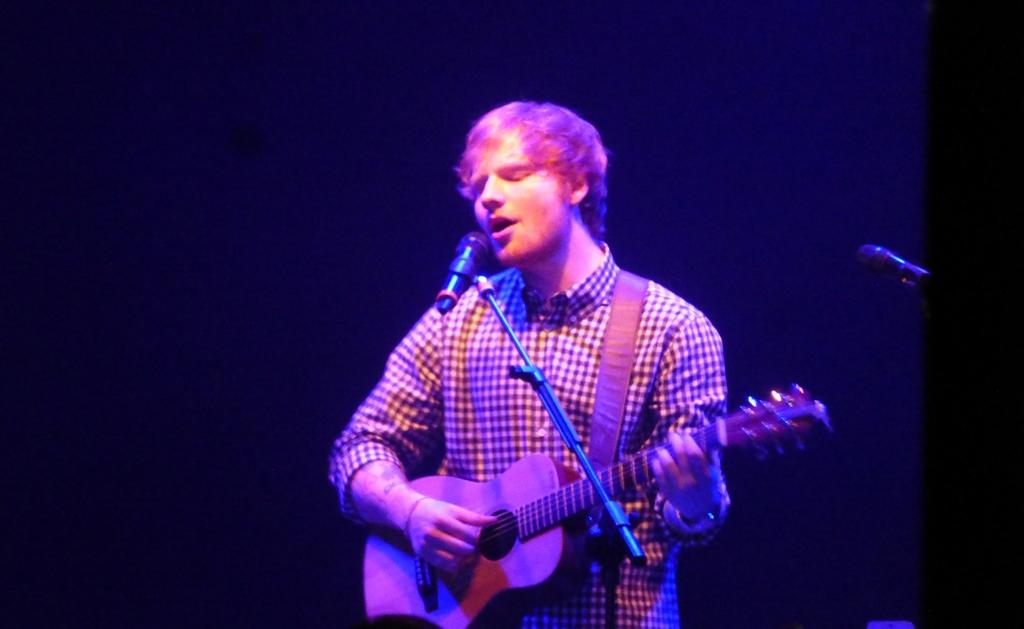What is the main subject of the image? There is a person in the image. What is the person wearing? The person is wearing a yellow and black shirt. What is the person doing in the image? The person is standing, singing, and playing a guitar. What object is in front of the person? There is a microphone in front of the person. What is the person's tendency to move in the direction of the current in the image? There is no reference to water or current in the image, so it is not possible to determine the person's tendency to move in that direction. 